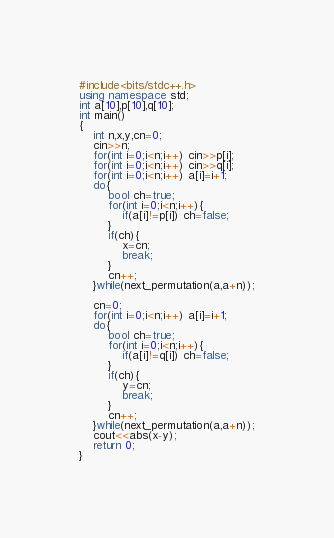<code> <loc_0><loc_0><loc_500><loc_500><_C++_>#include<bits/stdc++.h>
using namespace std;
int a[10],p[10],q[10];
int main()
{
	int n,x,y,cn=0;
	cin>>n;
	for(int i=0;i<n;i++) cin>>p[i];
	for(int i=0;i<n;i++) cin>>q[i];
	for(int i=0;i<n;i++) a[i]=i+1;
	do{
		bool ch=true;
		for(int i=0;i<n;i++){
			if(a[i]!=p[i]) ch=false;
		}
		if(ch){
			x=cn;
			break;
		}
		cn++;
	}while(next_permutation(a,a+n));
	
	cn=0;
	for(int i=0;i<n;i++) a[i]=i+1;
	do{
		bool ch=true;
		for(int i=0;i<n;i++){
			if(a[i]!=q[i]) ch=false;
		}
		if(ch){
			y=cn;
			break;
		}
		cn++;
	}while(next_permutation(a,a+n));
	cout<<abs(x-y);
	return 0;
}</code> 